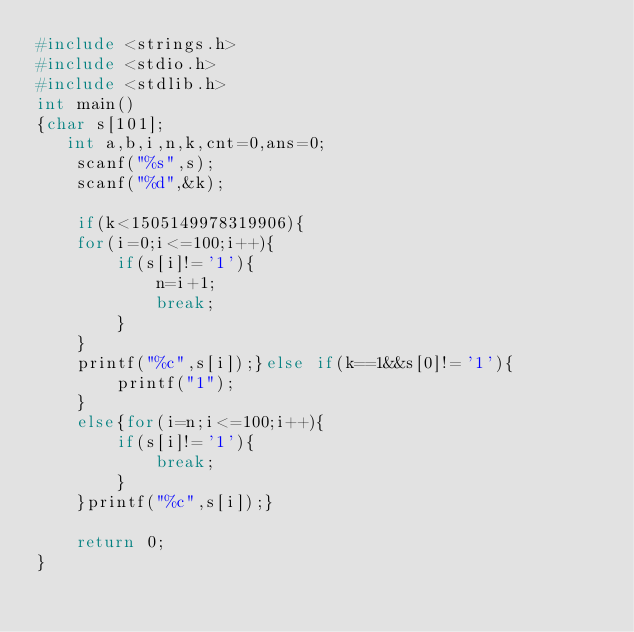Convert code to text. <code><loc_0><loc_0><loc_500><loc_500><_C_>#include <strings.h>
#include <stdio.h>
#include <stdlib.h>
int main()
{char s[101];
   int a,b,i,n,k,cnt=0,ans=0;
    scanf("%s",s);
    scanf("%d",&k);
    
    if(k<1505149978319906){
    for(i=0;i<=100;i++){
        if(s[i]!='1'){
            n=i+1;
            break;
        }
    }
    printf("%c",s[i]);}else if(k==1&&s[0]!='1'){
        printf("1");
    }
    else{for(i=n;i<=100;i++){
        if(s[i]!='1'){
            break;
        }
    }printf("%c",s[i]);}

    return 0;
}
</code> 